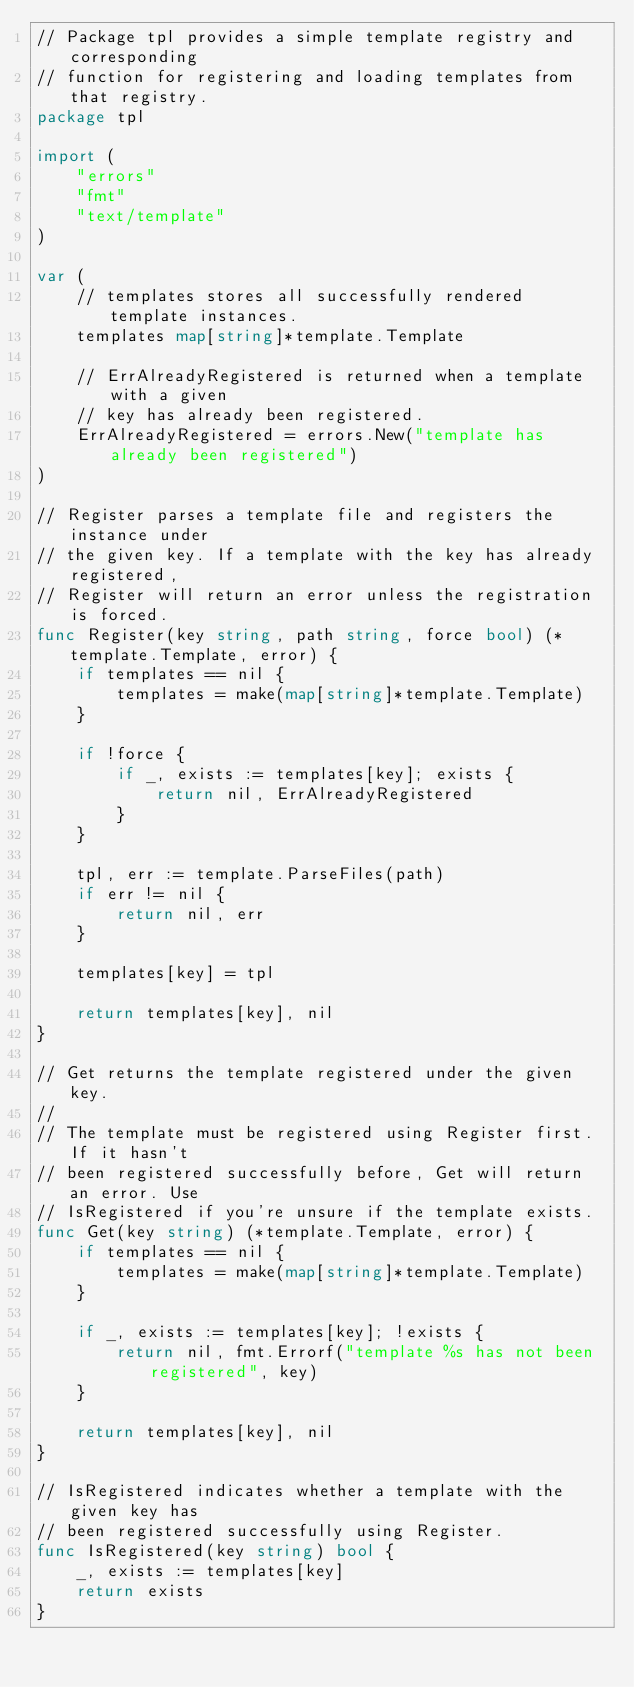<code> <loc_0><loc_0><loc_500><loc_500><_Go_>// Package tpl provides a simple template registry and corresponding
// function for registering and loading templates from that registry.
package tpl

import (
	"errors"
	"fmt"
	"text/template"
)

var (
	// templates stores all successfully rendered template instances.
	templates map[string]*template.Template

	// ErrAlreadyRegistered is returned when a template with a given
	// key has already been registered.
	ErrAlreadyRegistered = errors.New("template has already been registered")
)

// Register parses a template file and registers the instance under
// the given key. If a template with the key has already registered,
// Register will return an error unless the registration is forced.
func Register(key string, path string, force bool) (*template.Template, error) {
	if templates == nil {
		templates = make(map[string]*template.Template)
	}

	if !force {
		if _, exists := templates[key]; exists {
			return nil, ErrAlreadyRegistered
		}
	}

	tpl, err := template.ParseFiles(path)
	if err != nil {
		return nil, err
	}

	templates[key] = tpl

	return templates[key], nil
}

// Get returns the template registered under the given key.
//
// The template must be registered using Register first. If it hasn't
// been registered successfully before, Get will return an error. Use
// IsRegistered if you're unsure if the template exists.
func Get(key string) (*template.Template, error) {
	if templates == nil {
		templates = make(map[string]*template.Template)
	}

	if _, exists := templates[key]; !exists {
		return nil, fmt.Errorf("template %s has not been registered", key)
	}

	return templates[key], nil
}

// IsRegistered indicates whether a template with the given key has
// been registered successfully using Register.
func IsRegistered(key string) bool {
	_, exists := templates[key]
	return exists
}
</code> 